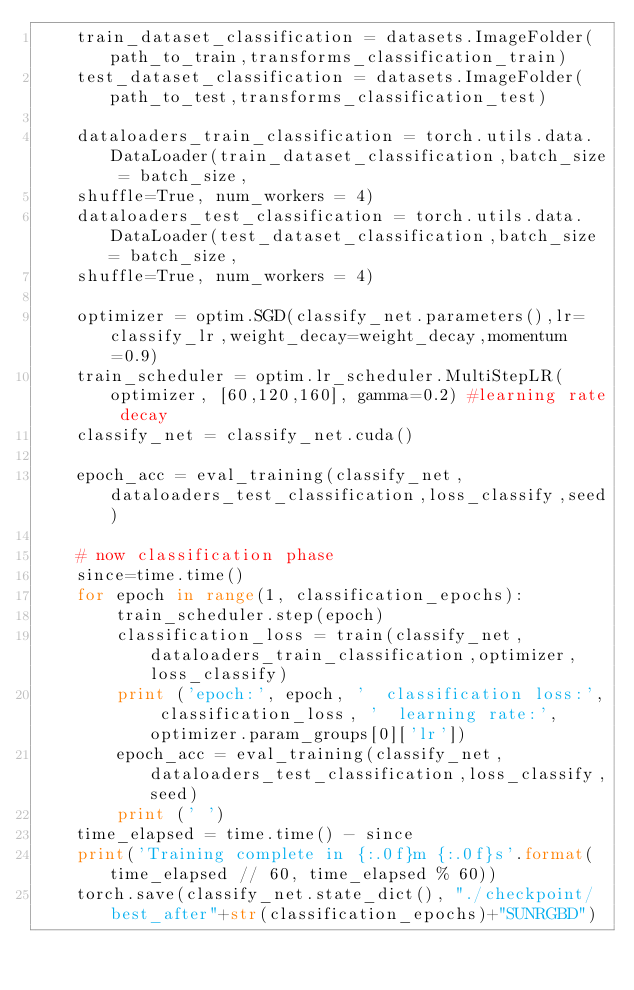Convert code to text. <code><loc_0><loc_0><loc_500><loc_500><_Python_>    train_dataset_classification = datasets.ImageFolder(path_to_train,transforms_classification_train)
    test_dataset_classification = datasets.ImageFolder(path_to_test,transforms_classification_test)

    dataloaders_train_classification = torch.utils.data.DataLoader(train_dataset_classification,batch_size = batch_size,
    shuffle=True, num_workers = 4)
    dataloaders_test_classification = torch.utils.data.DataLoader(test_dataset_classification,batch_size = batch_size,
    shuffle=True, num_workers = 4)

    optimizer = optim.SGD(classify_net.parameters(),lr=classify_lr,weight_decay=weight_decay,momentum=0.9)
    train_scheduler = optim.lr_scheduler.MultiStepLR(optimizer, [60,120,160], gamma=0.2) #learning rate decay
    classify_net = classify_net.cuda()

    epoch_acc = eval_training(classify_net,dataloaders_test_classification,loss_classify,seed)

    # now classification phase
    since=time.time()
    for epoch in range(1, classification_epochs):
        train_scheduler.step(epoch)
        classification_loss = train(classify_net,dataloaders_train_classification,optimizer,loss_classify)
        print ('epoch:', epoch, '  classification loss:', classification_loss, '  learning rate:', optimizer.param_groups[0]['lr'])
        epoch_acc = eval_training(classify_net,dataloaders_test_classification,loss_classify,seed)
        print (' ')
    time_elapsed = time.time() - since
    print('Training complete in {:.0f}m {:.0f}s'.format(time_elapsed // 60, time_elapsed % 60))
    torch.save(classify_net.state_dict(), "./checkpoint/best_after"+str(classification_epochs)+"SUNRGBD")
</code> 